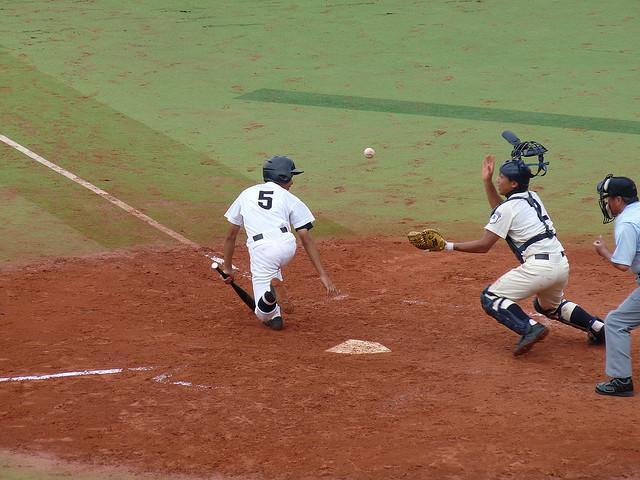How many people are in the picture?
Give a very brief answer. 3. 